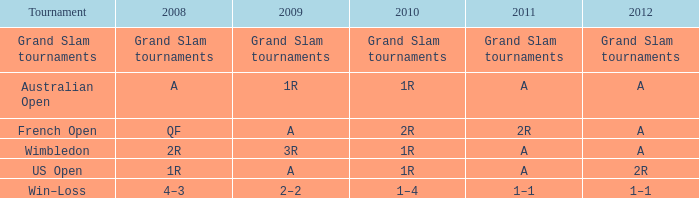Identify the competition taking place in 2011 with a 2r stage. French Open. Can you parse all the data within this table? {'header': ['Tournament', '2008', '2009', '2010', '2011', '2012'], 'rows': [['Grand Slam tournaments', 'Grand Slam tournaments', 'Grand Slam tournaments', 'Grand Slam tournaments', 'Grand Slam tournaments', 'Grand Slam tournaments'], ['Australian Open', 'A', '1R', '1R', 'A', 'A'], ['French Open', 'QF', 'A', '2R', '2R', 'A'], ['Wimbledon', '2R', '3R', '1R', 'A', 'A'], ['US Open', '1R', 'A', '1R', 'A', '2R'], ['Win–Loss', '4–3', '2–2', '1–4', '1–1', '1–1']]} 